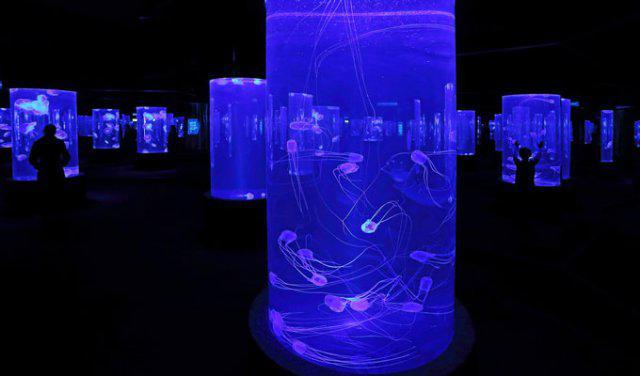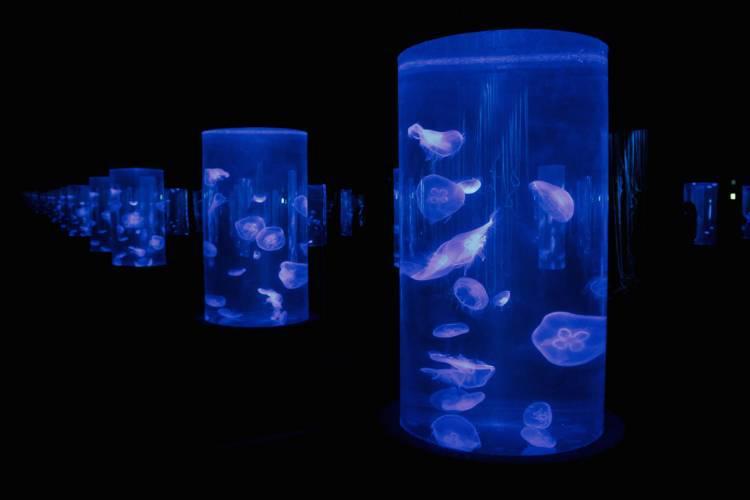The first image is the image on the left, the second image is the image on the right. Considering the images on both sides, is "An aquarium consists of multiple well lit geometrical shaped enclosures that have many types of sea creatures inside." valid? Answer yes or no. Yes. The first image is the image on the left, the second image is the image on the right. For the images shown, is this caption "multiple columned aquariums are holding jellyfish" true? Answer yes or no. Yes. 